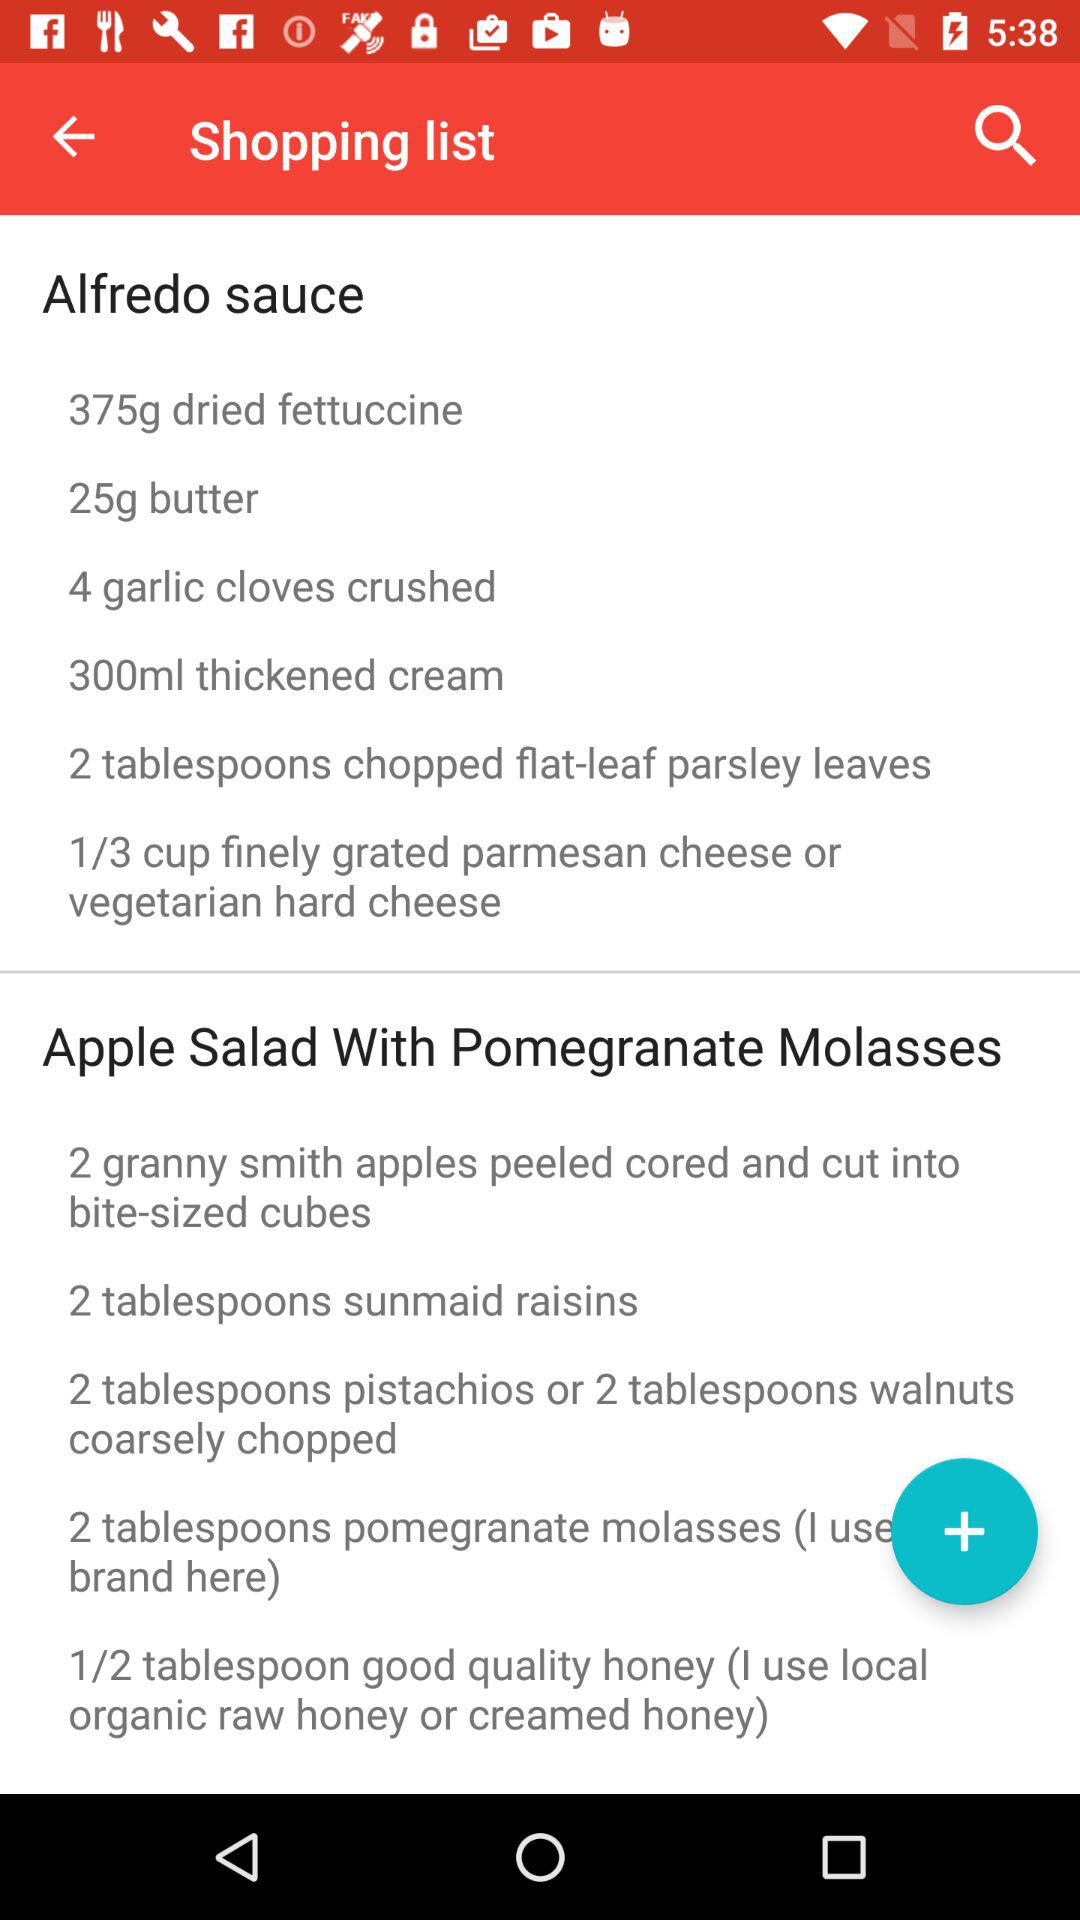How many tablespoons of Sunmaid raisins are required in apple salad? The number of tablespoons required is 2. 